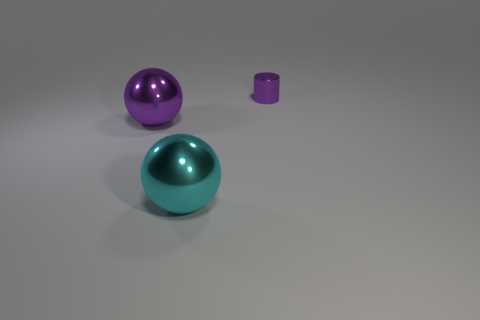Add 1 large purple spheres. How many objects exist? 4 Subtract all cylinders. How many objects are left? 2 Subtract all tiny cylinders. Subtract all metallic balls. How many objects are left? 0 Add 1 large objects. How many large objects are left? 3 Add 1 tiny cylinders. How many tiny cylinders exist? 2 Subtract 0 green cylinders. How many objects are left? 3 